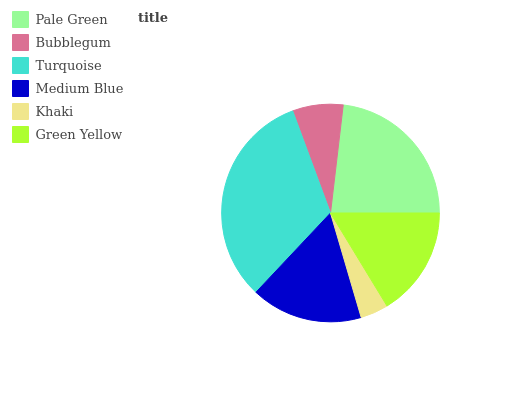Is Khaki the minimum?
Answer yes or no. Yes. Is Turquoise the maximum?
Answer yes or no. Yes. Is Bubblegum the minimum?
Answer yes or no. No. Is Bubblegum the maximum?
Answer yes or no. No. Is Pale Green greater than Bubblegum?
Answer yes or no. Yes. Is Bubblegum less than Pale Green?
Answer yes or no. Yes. Is Bubblegum greater than Pale Green?
Answer yes or no. No. Is Pale Green less than Bubblegum?
Answer yes or no. No. Is Medium Blue the high median?
Answer yes or no. Yes. Is Green Yellow the low median?
Answer yes or no. Yes. Is Bubblegum the high median?
Answer yes or no. No. Is Bubblegum the low median?
Answer yes or no. No. 